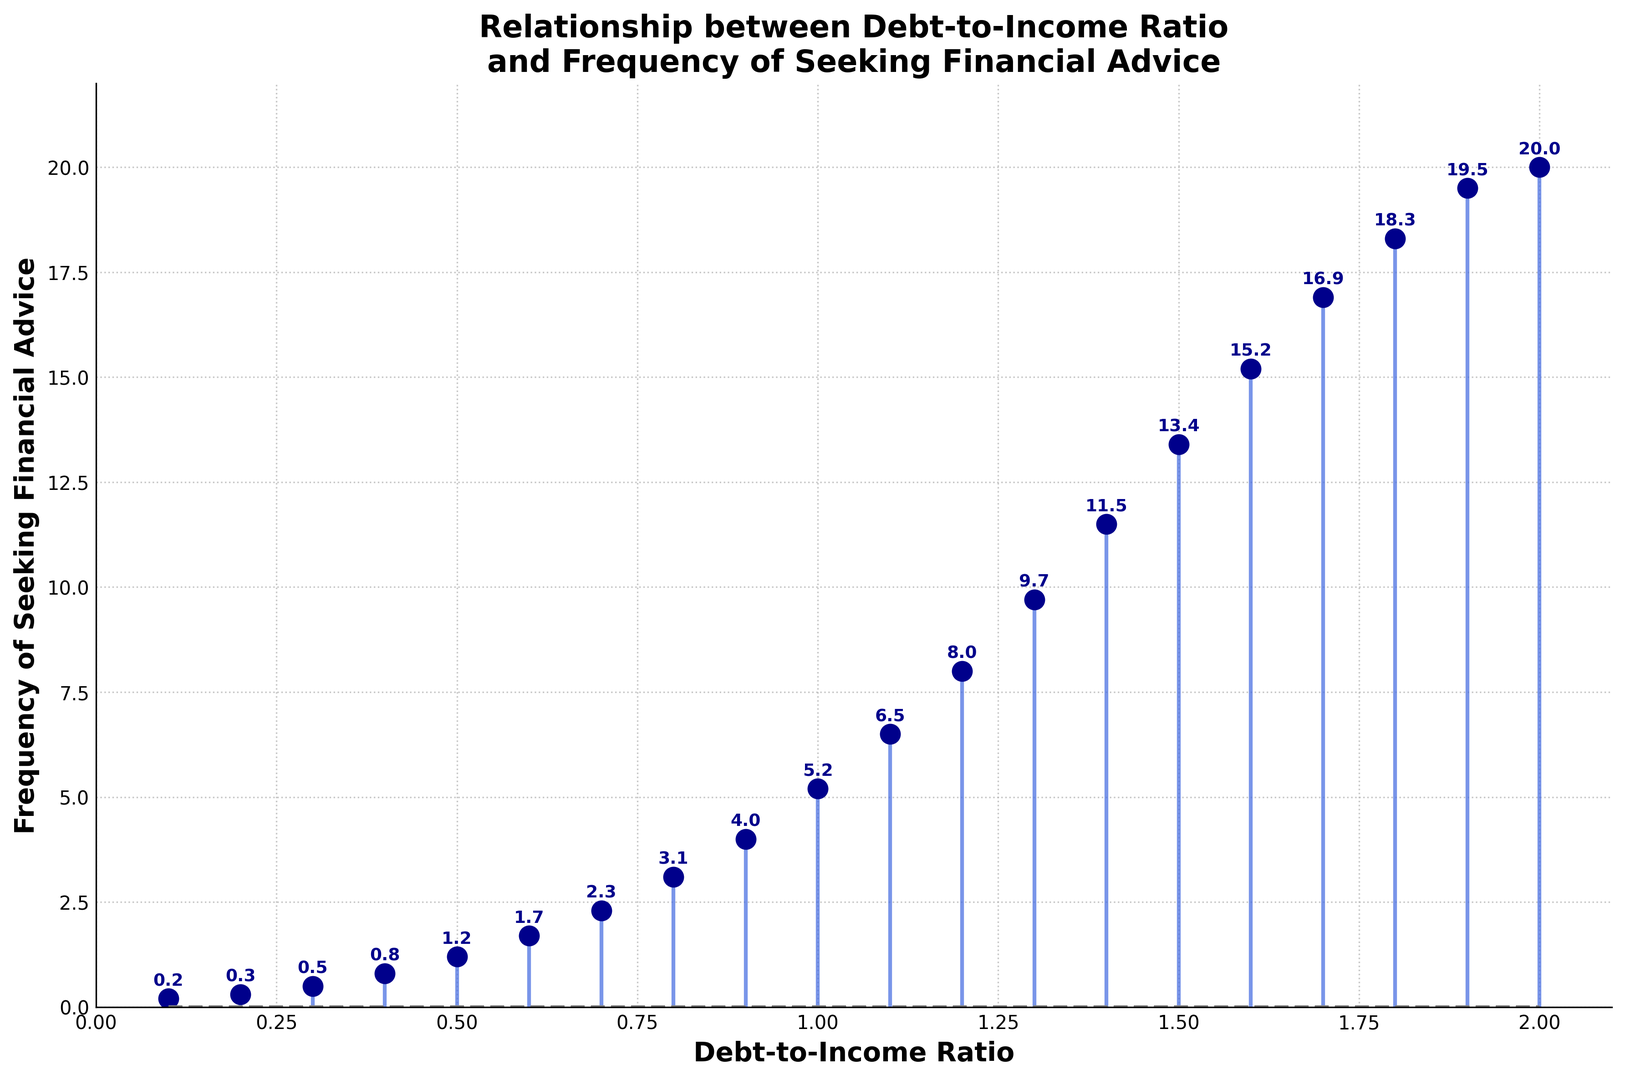What's the highest value on the Frequency of Seeking Financial Advice axis? To find the highest value, look at the y-axis and identify the largest number. The y-axis is labeled "Frequency of Seeking Financial Advice," with the highest value showing 20.0.
Answer: 20.0 What's the Debt-to-Income Ratio when the frequency of seeking financial advice is 3.1? Locate the point on the graph where the y-value is 3.1, then trace directly down to the x-axis to find the corresponding Debt-to-Income Ratio.
Answer: 0.8 At what Debt-to-Income Ratio does the frequency of seeking financial advice first exceed 10.0? Identify when the y-value first surpasses 10.0, and then trace down to find the x-value just above this point. This happens between 1.3 and 1.4 Debt-to-Income Ratio values, with the first point at exactly 1.4.
Answer: 1.4 Compare the frequency of seeking financial advice at a Debt-to-Income Ratio of 0.5 and 1.0. Which is higher and by how much? Locate the y-values for the given x-values (0.5 and 1.0). The frequencies are 1.2 and 5.2, respectively. Subtract the smaller value from the larger one: 5.2 - 1.2 = 4.0.
Answer: 1.0 by 4.0 What's the average frequency of seeking financial advice at Debt-to-Income Ratios of 0.1, 0.5, and 0.9? Find the corresponding y-values: 0.2, 1.2, and 4.0. Sum these: 0.2 + 1.2 + 4.0 = 5.4. Then divide by 3: 5.4 / 3 = 1.8.
Answer: 1.8 How does the frequency of seeking financial advice change as Debt-to-Income Ratios increase from 0.6 to 0.7? Observe the y-values for x-values 0.6 and 0.7, which are 1.7 and 2.3, respectively. The difference is 2.3 - 1.7 = 0.6, indicating an increase.
Answer: It increases by 0.6 What is the difference in frequency of seeking financial advice between the highest and lowest Debt-to-Income Ratios shown? Find the frequencies at the highest (2.0) and the lowest (0.1) Debt-to-Income Ratios, which are 20.0 and 0.2, respectively. Calculate the difference: 20.0 - 0.2 = 19.8.
Answer: 19.8 Does the plot show more frequent advice-seeking behavior at higher or lower Debt-to-Income Ratios? Analyze the trend in the plot, where the y-values increase as the x-values (Debt-to-Income Ratios) increase. This indicates higher advice-seeking behavior at higher ratios.
Answer: Higher Debt-to-Income Ratios 